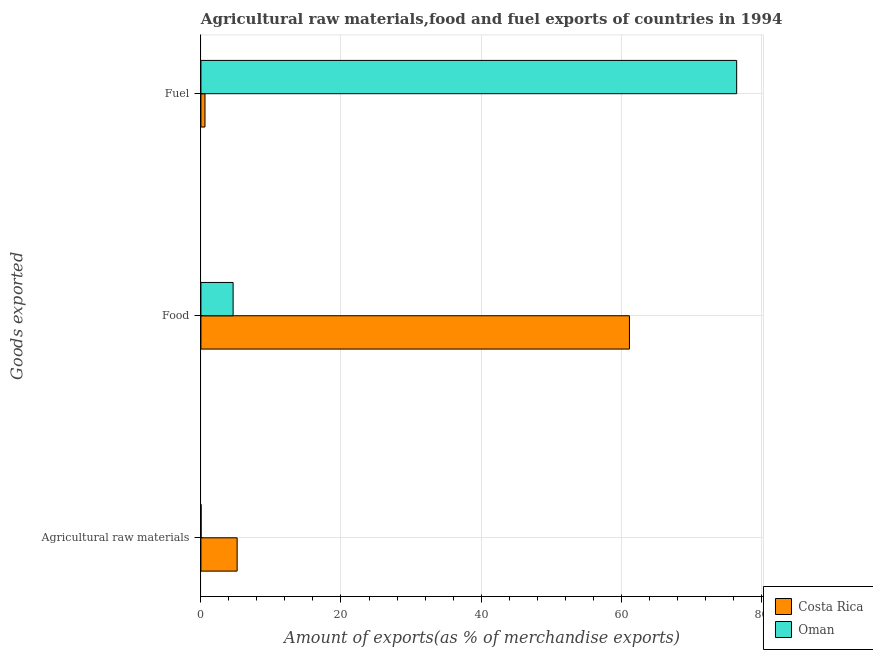How many different coloured bars are there?
Offer a terse response. 2. How many groups of bars are there?
Provide a succinct answer. 3. Are the number of bars on each tick of the Y-axis equal?
Offer a very short reply. Yes. How many bars are there on the 2nd tick from the top?
Provide a short and direct response. 2. How many bars are there on the 3rd tick from the bottom?
Keep it short and to the point. 2. What is the label of the 2nd group of bars from the top?
Offer a terse response. Food. What is the percentage of raw materials exports in Costa Rica?
Your response must be concise. 5.17. Across all countries, what is the maximum percentage of fuel exports?
Your answer should be compact. 76.5. Across all countries, what is the minimum percentage of raw materials exports?
Make the answer very short. 0.02. In which country was the percentage of raw materials exports minimum?
Make the answer very short. Oman. What is the total percentage of raw materials exports in the graph?
Your answer should be very brief. 5.2. What is the difference between the percentage of fuel exports in Costa Rica and that in Oman?
Keep it short and to the point. -75.91. What is the difference between the percentage of raw materials exports in Oman and the percentage of fuel exports in Costa Rica?
Provide a short and direct response. -0.56. What is the average percentage of fuel exports per country?
Make the answer very short. 38.54. What is the difference between the percentage of food exports and percentage of fuel exports in Costa Rica?
Keep it short and to the point. 60.6. What is the ratio of the percentage of fuel exports in Costa Rica to that in Oman?
Your answer should be very brief. 0.01. What is the difference between the highest and the second highest percentage of food exports?
Offer a very short reply. 56.59. What is the difference between the highest and the lowest percentage of fuel exports?
Offer a terse response. 75.91. What does the 1st bar from the top in Agricultural raw materials represents?
Your answer should be very brief. Oman. What does the 2nd bar from the bottom in Agricultural raw materials represents?
Offer a terse response. Oman. Is it the case that in every country, the sum of the percentage of raw materials exports and percentage of food exports is greater than the percentage of fuel exports?
Your answer should be compact. No. How many bars are there?
Keep it short and to the point. 6. Does the graph contain any zero values?
Provide a short and direct response. No. Does the graph contain grids?
Your answer should be compact. Yes. Where does the legend appear in the graph?
Offer a very short reply. Bottom right. How are the legend labels stacked?
Make the answer very short. Vertical. What is the title of the graph?
Offer a terse response. Agricultural raw materials,food and fuel exports of countries in 1994. Does "Maldives" appear as one of the legend labels in the graph?
Your response must be concise. No. What is the label or title of the X-axis?
Your response must be concise. Amount of exports(as % of merchandise exports). What is the label or title of the Y-axis?
Make the answer very short. Goods exported. What is the Amount of exports(as % of merchandise exports) in Costa Rica in Agricultural raw materials?
Offer a terse response. 5.17. What is the Amount of exports(as % of merchandise exports) in Oman in Agricultural raw materials?
Your answer should be compact. 0.02. What is the Amount of exports(as % of merchandise exports) in Costa Rica in Food?
Your response must be concise. 61.19. What is the Amount of exports(as % of merchandise exports) in Oman in Food?
Your response must be concise. 4.6. What is the Amount of exports(as % of merchandise exports) in Costa Rica in Fuel?
Provide a short and direct response. 0.58. What is the Amount of exports(as % of merchandise exports) in Oman in Fuel?
Ensure brevity in your answer.  76.5. Across all Goods exported, what is the maximum Amount of exports(as % of merchandise exports) in Costa Rica?
Give a very brief answer. 61.19. Across all Goods exported, what is the maximum Amount of exports(as % of merchandise exports) of Oman?
Keep it short and to the point. 76.5. Across all Goods exported, what is the minimum Amount of exports(as % of merchandise exports) in Costa Rica?
Make the answer very short. 0.58. Across all Goods exported, what is the minimum Amount of exports(as % of merchandise exports) in Oman?
Provide a succinct answer. 0.02. What is the total Amount of exports(as % of merchandise exports) of Costa Rica in the graph?
Give a very brief answer. 66.94. What is the total Amount of exports(as % of merchandise exports) in Oman in the graph?
Keep it short and to the point. 81.12. What is the difference between the Amount of exports(as % of merchandise exports) in Costa Rica in Agricultural raw materials and that in Food?
Offer a very short reply. -56.01. What is the difference between the Amount of exports(as % of merchandise exports) of Oman in Agricultural raw materials and that in Food?
Your answer should be very brief. -4.57. What is the difference between the Amount of exports(as % of merchandise exports) of Costa Rica in Agricultural raw materials and that in Fuel?
Your response must be concise. 4.59. What is the difference between the Amount of exports(as % of merchandise exports) of Oman in Agricultural raw materials and that in Fuel?
Offer a very short reply. -76.47. What is the difference between the Amount of exports(as % of merchandise exports) of Costa Rica in Food and that in Fuel?
Your response must be concise. 60.6. What is the difference between the Amount of exports(as % of merchandise exports) in Oman in Food and that in Fuel?
Your answer should be very brief. -71.9. What is the difference between the Amount of exports(as % of merchandise exports) of Costa Rica in Agricultural raw materials and the Amount of exports(as % of merchandise exports) of Oman in Food?
Offer a terse response. 0.58. What is the difference between the Amount of exports(as % of merchandise exports) of Costa Rica in Agricultural raw materials and the Amount of exports(as % of merchandise exports) of Oman in Fuel?
Provide a short and direct response. -71.32. What is the difference between the Amount of exports(as % of merchandise exports) in Costa Rica in Food and the Amount of exports(as % of merchandise exports) in Oman in Fuel?
Ensure brevity in your answer.  -15.31. What is the average Amount of exports(as % of merchandise exports) of Costa Rica per Goods exported?
Keep it short and to the point. 22.31. What is the average Amount of exports(as % of merchandise exports) in Oman per Goods exported?
Provide a short and direct response. 27.04. What is the difference between the Amount of exports(as % of merchandise exports) of Costa Rica and Amount of exports(as % of merchandise exports) of Oman in Agricultural raw materials?
Make the answer very short. 5.15. What is the difference between the Amount of exports(as % of merchandise exports) in Costa Rica and Amount of exports(as % of merchandise exports) in Oman in Food?
Provide a short and direct response. 56.59. What is the difference between the Amount of exports(as % of merchandise exports) of Costa Rica and Amount of exports(as % of merchandise exports) of Oman in Fuel?
Offer a very short reply. -75.91. What is the ratio of the Amount of exports(as % of merchandise exports) in Costa Rica in Agricultural raw materials to that in Food?
Make the answer very short. 0.08. What is the ratio of the Amount of exports(as % of merchandise exports) in Oman in Agricultural raw materials to that in Food?
Provide a succinct answer. 0.01. What is the ratio of the Amount of exports(as % of merchandise exports) in Costa Rica in Agricultural raw materials to that in Fuel?
Offer a terse response. 8.91. What is the ratio of the Amount of exports(as % of merchandise exports) of Oman in Agricultural raw materials to that in Fuel?
Provide a short and direct response. 0. What is the ratio of the Amount of exports(as % of merchandise exports) of Costa Rica in Food to that in Fuel?
Keep it short and to the point. 105.37. What is the ratio of the Amount of exports(as % of merchandise exports) of Oman in Food to that in Fuel?
Make the answer very short. 0.06. What is the difference between the highest and the second highest Amount of exports(as % of merchandise exports) in Costa Rica?
Make the answer very short. 56.01. What is the difference between the highest and the second highest Amount of exports(as % of merchandise exports) in Oman?
Offer a very short reply. 71.9. What is the difference between the highest and the lowest Amount of exports(as % of merchandise exports) in Costa Rica?
Give a very brief answer. 60.6. What is the difference between the highest and the lowest Amount of exports(as % of merchandise exports) in Oman?
Provide a succinct answer. 76.47. 